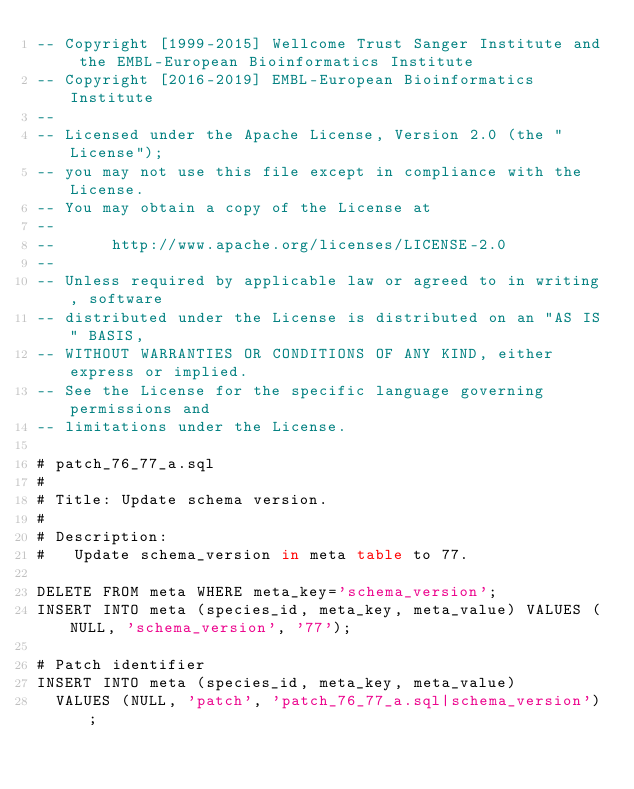Convert code to text. <code><loc_0><loc_0><loc_500><loc_500><_SQL_>-- Copyright [1999-2015] Wellcome Trust Sanger Institute and the EMBL-European Bioinformatics Institute
-- Copyright [2016-2019] EMBL-European Bioinformatics Institute
-- 
-- Licensed under the Apache License, Version 2.0 (the "License");
-- you may not use this file except in compliance with the License.
-- You may obtain a copy of the License at
-- 
--      http://www.apache.org/licenses/LICENSE-2.0
-- 
-- Unless required by applicable law or agreed to in writing, software
-- distributed under the License is distributed on an "AS IS" BASIS,
-- WITHOUT WARRANTIES OR CONDITIONS OF ANY KIND, either express or implied.
-- See the License for the specific language governing permissions and
-- limitations under the License.

# patch_76_77_a.sql
#
# Title: Update schema version.
#
# Description:
#   Update schema_version in meta table to 77.

DELETE FROM meta WHERE meta_key='schema_version';
INSERT INTO meta (species_id, meta_key, meta_value) VALUES (NULL, 'schema_version', '77');

# Patch identifier
INSERT INTO meta (species_id, meta_key, meta_value)
  VALUES (NULL, 'patch', 'patch_76_77_a.sql|schema_version');
</code> 